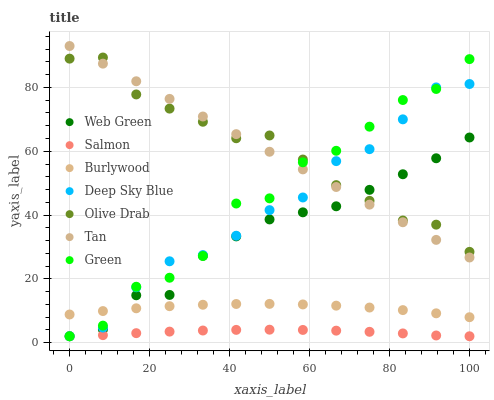Does Salmon have the minimum area under the curve?
Answer yes or no. Yes. Does Olive Drab have the maximum area under the curve?
Answer yes or no. Yes. Does Web Green have the minimum area under the curve?
Answer yes or no. No. Does Web Green have the maximum area under the curve?
Answer yes or no. No. Is Tan the smoothest?
Answer yes or no. Yes. Is Green the roughest?
Answer yes or no. Yes. Is Salmon the smoothest?
Answer yes or no. No. Is Salmon the roughest?
Answer yes or no. No. Does Salmon have the lowest value?
Answer yes or no. Yes. Does Tan have the lowest value?
Answer yes or no. No. Does Tan have the highest value?
Answer yes or no. Yes. Does Web Green have the highest value?
Answer yes or no. No. Is Burlywood less than Olive Drab?
Answer yes or no. Yes. Is Olive Drab greater than Burlywood?
Answer yes or no. Yes. Does Deep Sky Blue intersect Green?
Answer yes or no. Yes. Is Deep Sky Blue less than Green?
Answer yes or no. No. Is Deep Sky Blue greater than Green?
Answer yes or no. No. Does Burlywood intersect Olive Drab?
Answer yes or no. No. 